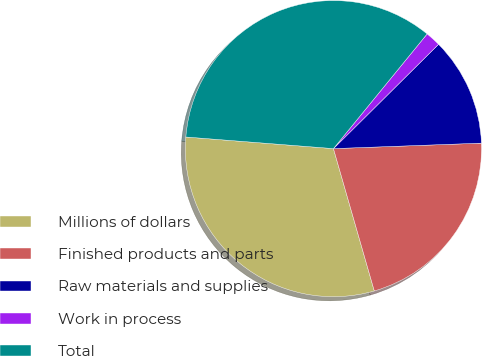<chart> <loc_0><loc_0><loc_500><loc_500><pie_chart><fcel>Millions of dollars<fcel>Finished products and parts<fcel>Raw materials and supplies<fcel>Work in process<fcel>Total<nl><fcel>30.7%<fcel>21.14%<fcel>11.85%<fcel>1.66%<fcel>34.65%<nl></chart> 